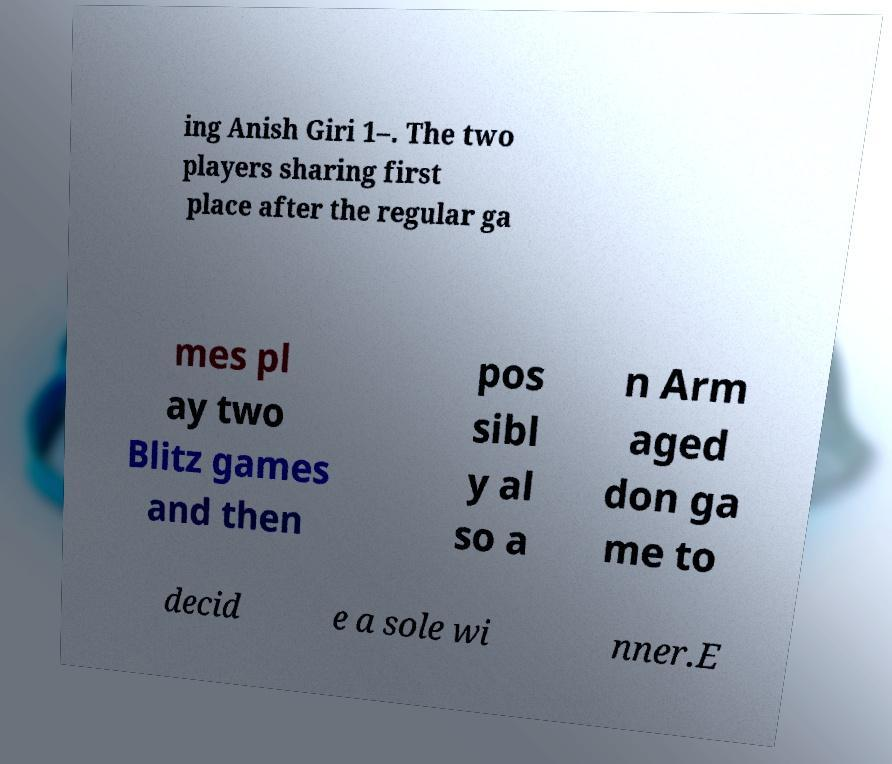What messages or text are displayed in this image? I need them in a readable, typed format. ing Anish Giri 1–. The two players sharing first place after the regular ga mes pl ay two Blitz games and then pos sibl y al so a n Arm aged don ga me to decid e a sole wi nner.E 